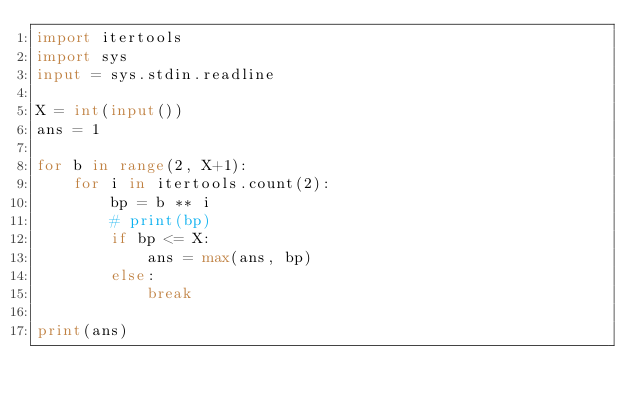Convert code to text. <code><loc_0><loc_0><loc_500><loc_500><_Python_>import itertools
import sys
input = sys.stdin.readline

X = int(input())
ans = 1

for b in range(2, X+1):
    for i in itertools.count(2):
        bp = b ** i
        # print(bp)
        if bp <= X:
            ans = max(ans, bp)
        else:
            break

print(ans)
</code> 